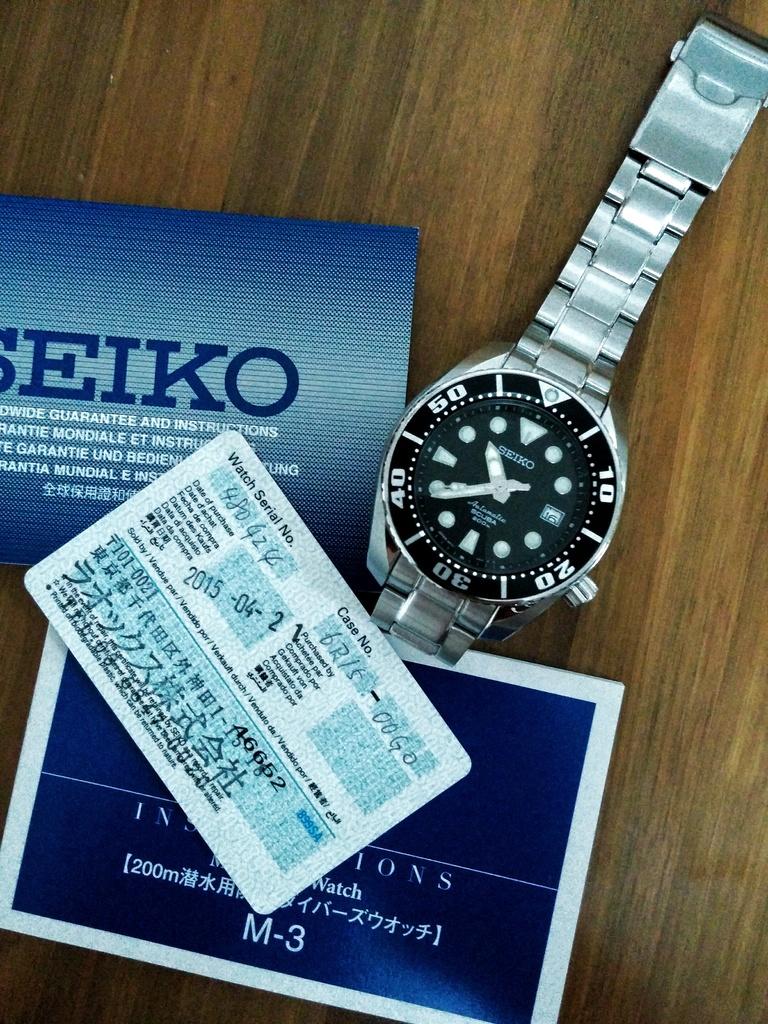What brand of watch is this?
Make the answer very short. Seiko. What is the number after "m" at the bottom?
Provide a succinct answer. 3. 